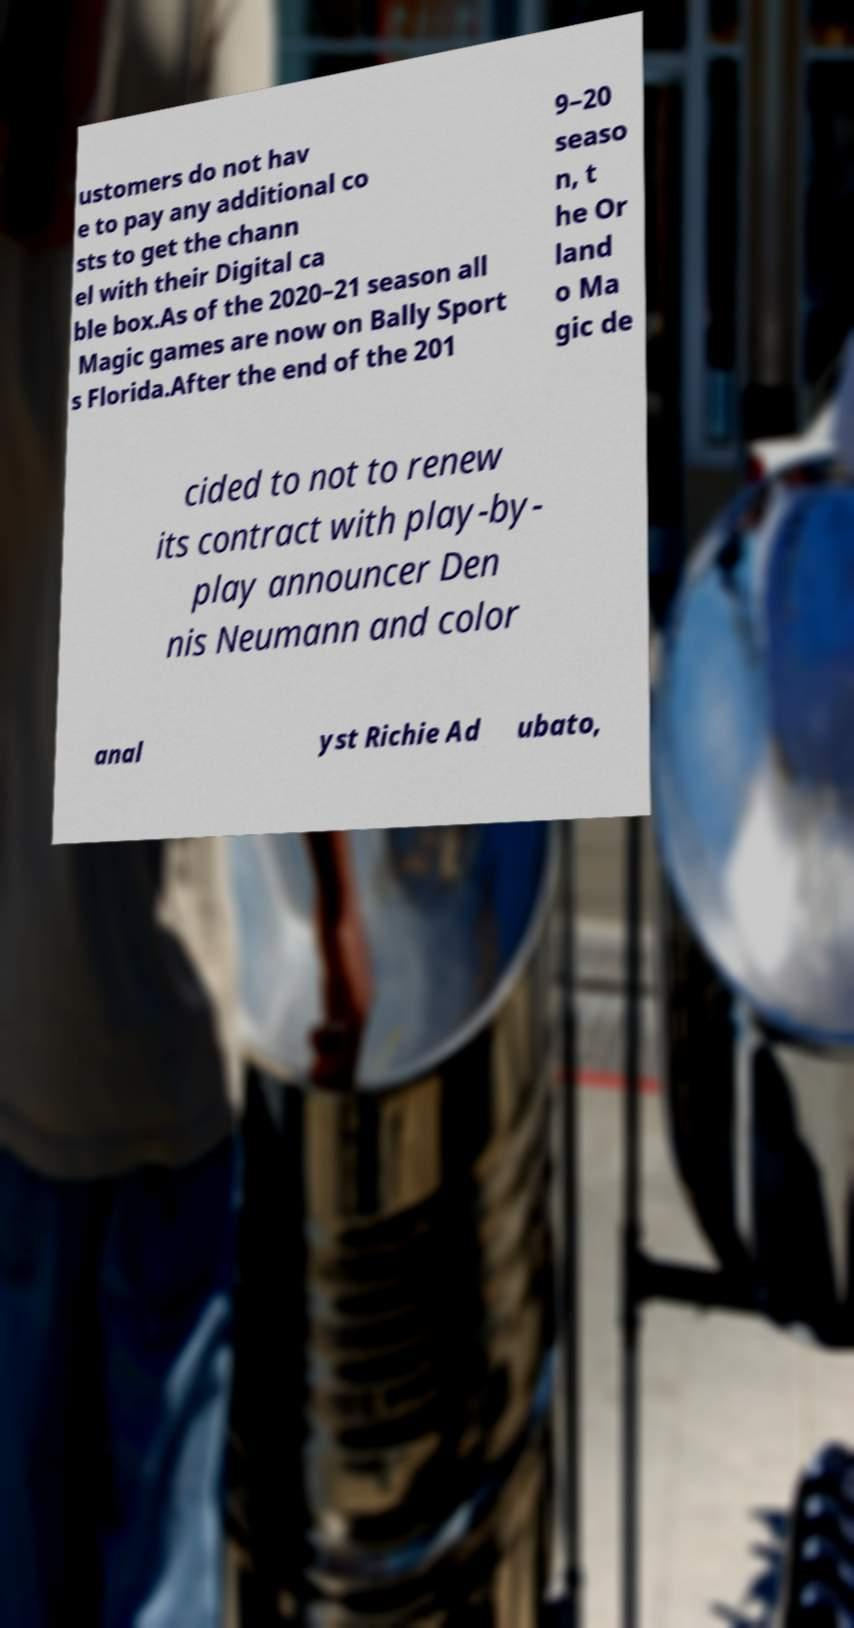Can you read and provide the text displayed in the image?This photo seems to have some interesting text. Can you extract and type it out for me? ustomers do not hav e to pay any additional co sts to get the chann el with their Digital ca ble box.As of the 2020–21 season all Magic games are now on Bally Sport s Florida.After the end of the 201 9–20 seaso n, t he Or land o Ma gic de cided to not to renew its contract with play-by- play announcer Den nis Neumann and color anal yst Richie Ad ubato, 